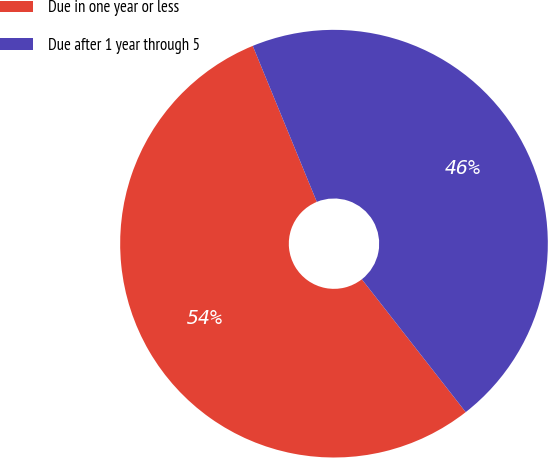<chart> <loc_0><loc_0><loc_500><loc_500><pie_chart><fcel>Due in one year or less<fcel>Due after 1 year through 5<nl><fcel>54.36%<fcel>45.64%<nl></chart> 